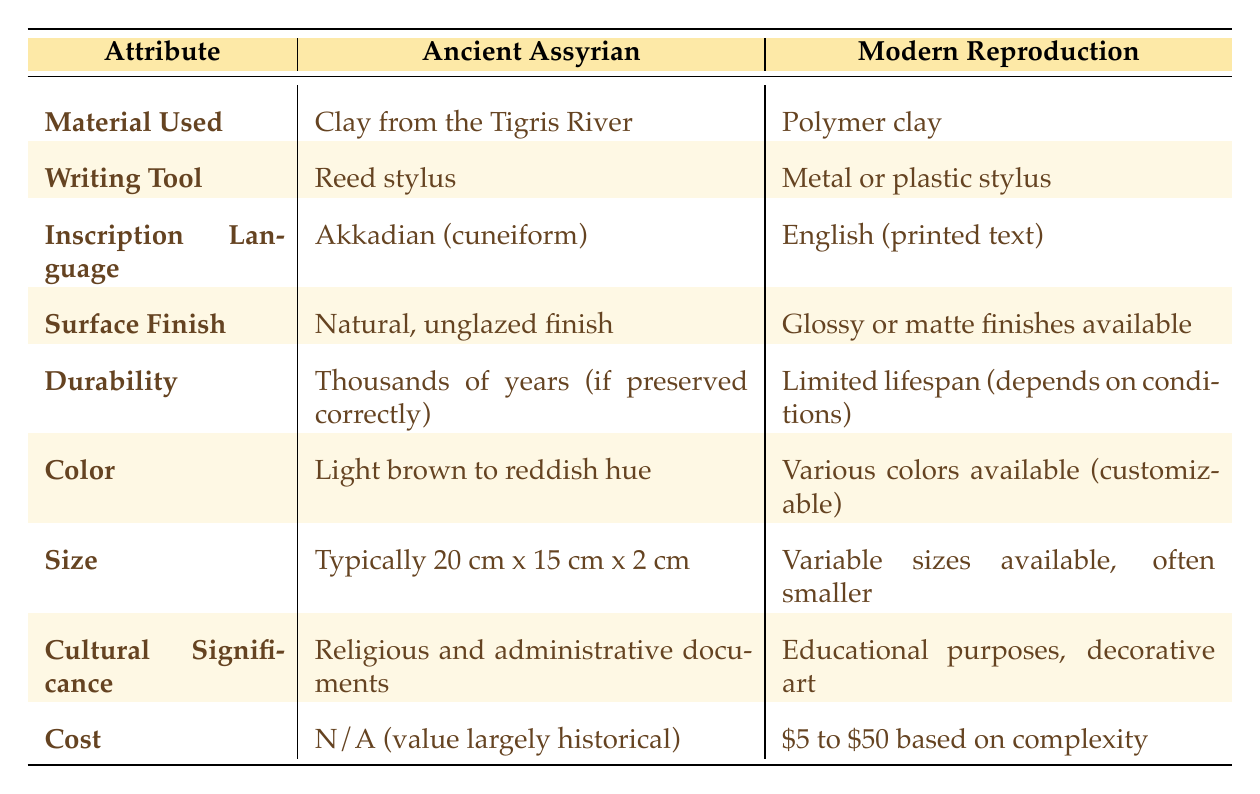What was the material used for ancient Assyrian tablets? According to the table, the material used was "Clay from the Tigris River."
Answer: Clay from the Tigris River What color were the ancient Assyrian tablets? The table states that the color of ancient Assyrian tablets was "Light brown to reddish hue."
Answer: Light brown to reddish hue Is the inscription language the same for both ancient Assyrian tablets and modern reproductions? The table shows that the ancient Assyrian tablets used "Akkadian (cuneiform)" while modern reproductions use "English (printed text)," so they are not the same.
Answer: No What surface finish options are available for modern reproductions? The table indicates that modern reproductions have "Glossy or matte finishes available."
Answer: Glossy or matte finishes available How long can ancient Assyrian tablets last if preserved correctly? The table states that ancient Assyrian tablets can last for "Thousands of years (if preserved correctly)."
Answer: Thousands of years (if preserved correctly) Compared to ancient Assyrian tablets, are modern reproductions more culturally significant? The ancient Assyrian tablets were primarily used for "Religious and administrative documents," whereas modern reproductions are for "Educational purposes, decorative art." This indicates a difference in significance.
Answer: Yes, they are different What is the cost range for modern reproductions? The table mentions that modern reproductions range from "$5 to $50 based on complexity."
Answer: $5 to $50 If an ancient Assyrian tablet typically measured 20 cm x 15 cm x 2 cm, how does this compare in size to modern reproductions? The table states that ancient Assyrian tablets were "Typically 20 cm x 15 cm x 2 cm," while modern reproductions have "Variable sizes available, often smaller." This indicates that modern reproductions can vary and are generally smaller.
Answer: Modern reproductions are often smaller What writing tool was used for ancient Assyrian tablets? As per the table, the writing tool used for ancient Assyrian tablets was a "Reed stylus."
Answer: Reed stylus 